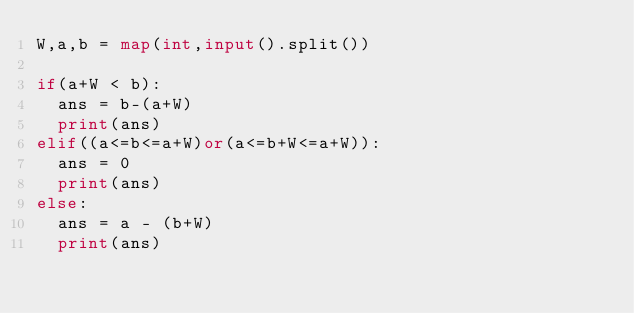Convert code to text. <code><loc_0><loc_0><loc_500><loc_500><_Python_>W,a,b = map(int,input().split())

if(a+W < b):
  ans = b-(a+W)
  print(ans)
elif((a<=b<=a+W)or(a<=b+W<=a+W)):
  ans = 0
  print(ans)
else:
  ans = a - (b+W)
  print(ans)
  </code> 